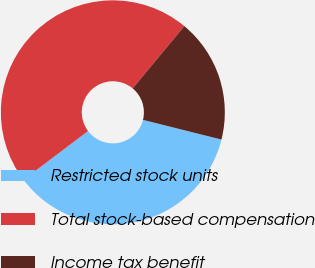Convert chart to OTSL. <chart><loc_0><loc_0><loc_500><loc_500><pie_chart><fcel>Restricted stock units<fcel>Total stock-based compensation<fcel>Income tax benefit<nl><fcel>35.79%<fcel>46.32%<fcel>17.89%<nl></chart> 